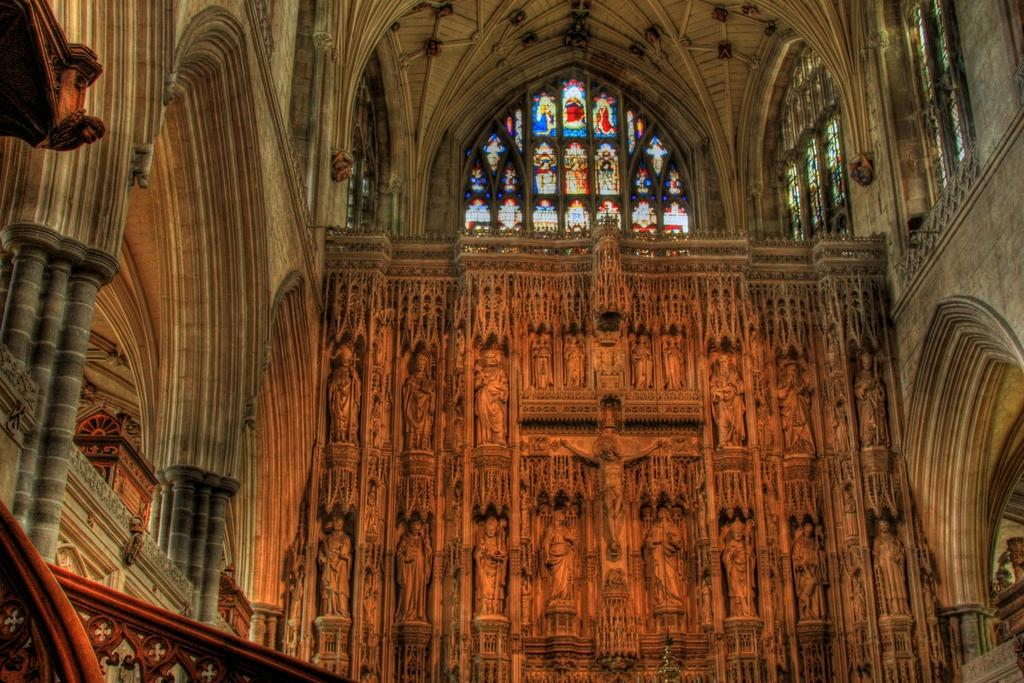What type of location is depicted in the image? The image shows an inside view of a building. What decorative elements can be seen in the image? There are statues and pillars present in the image. What feature of the windows is noteworthy in the image? There are designs on the window glasses. What else can be seen in the image besides the statues, pillars, and window designs? There are objects visible in the image. What type of plough is being used to cultivate the field in the image? There is no field or plough present in the image; it shows an inside view of a building. How many cushions are visible on the chairs in the image? There are no cushions visible in the image; it only shows statues, pillars, window designs, and other objects. 